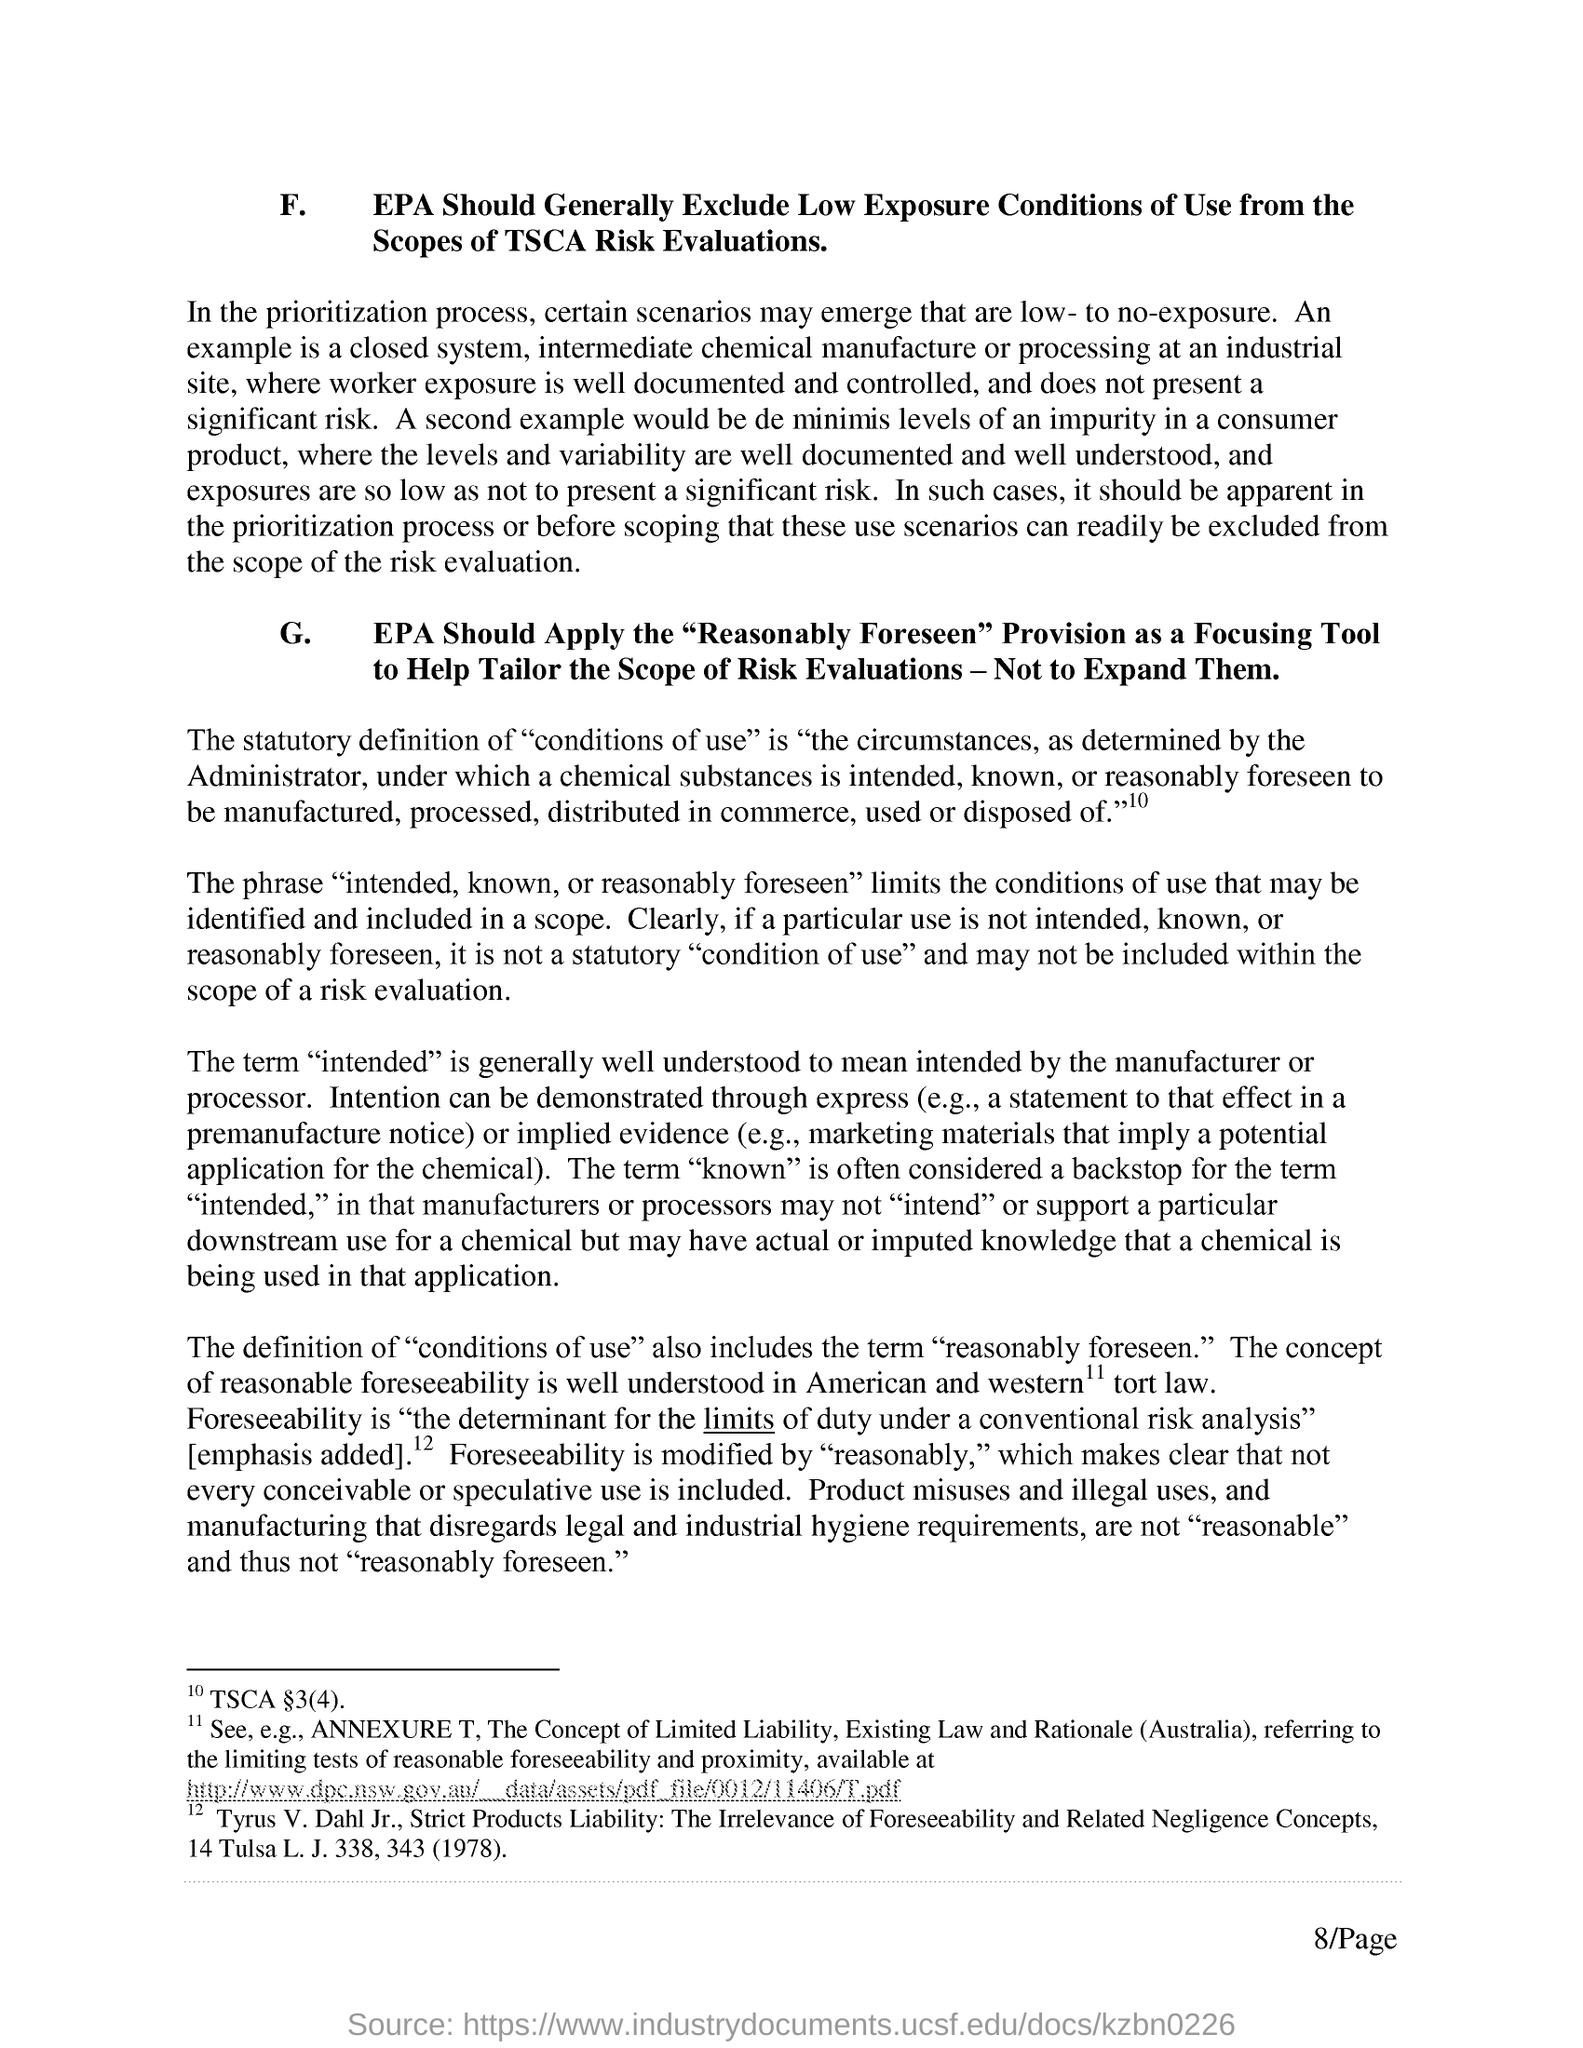Draw attention to some important aspects in this diagram. The "Reasonably Foreseen" provision should be applied as a focusing tool by the Environmental Protection Agency (EPA) to prioritize its regulatory activities. Foreseeability is the determinant of the limits of duty under a conventional risk analysis. The Environmental Protection Agency (EPA) should exclude low exposure conditions of use from the scope of TSCA risk evaluations. 